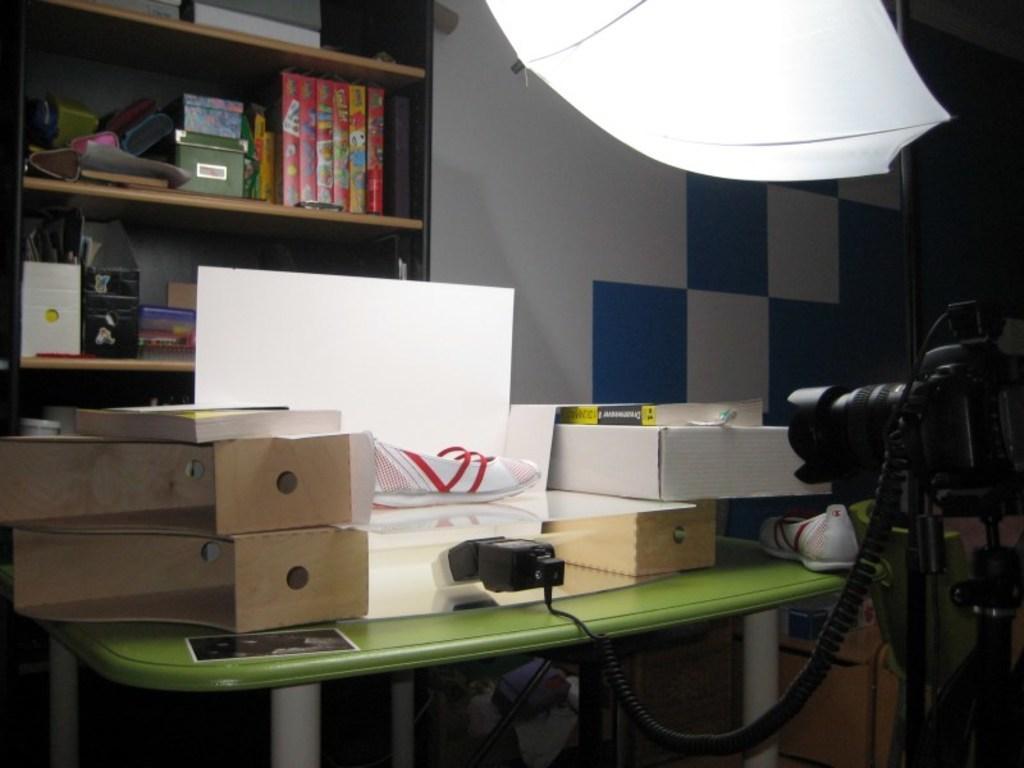Could you give a brief overview of what you see in this image? In the picture i can see a table on which there are some cardboard boxes, electronic devices, on right side of the picture there is camera and on left side of the picture there is cupboard in which some books and other items are arranged in shelves, top of the picture there is umbrella. 